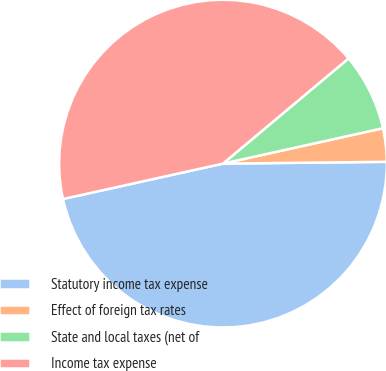Convert chart to OTSL. <chart><loc_0><loc_0><loc_500><loc_500><pie_chart><fcel>Statutory income tax expense<fcel>Effect of foreign tax rates<fcel>State and local taxes (net of<fcel>Income tax expense<nl><fcel>46.71%<fcel>3.29%<fcel>7.63%<fcel>42.37%<nl></chart> 